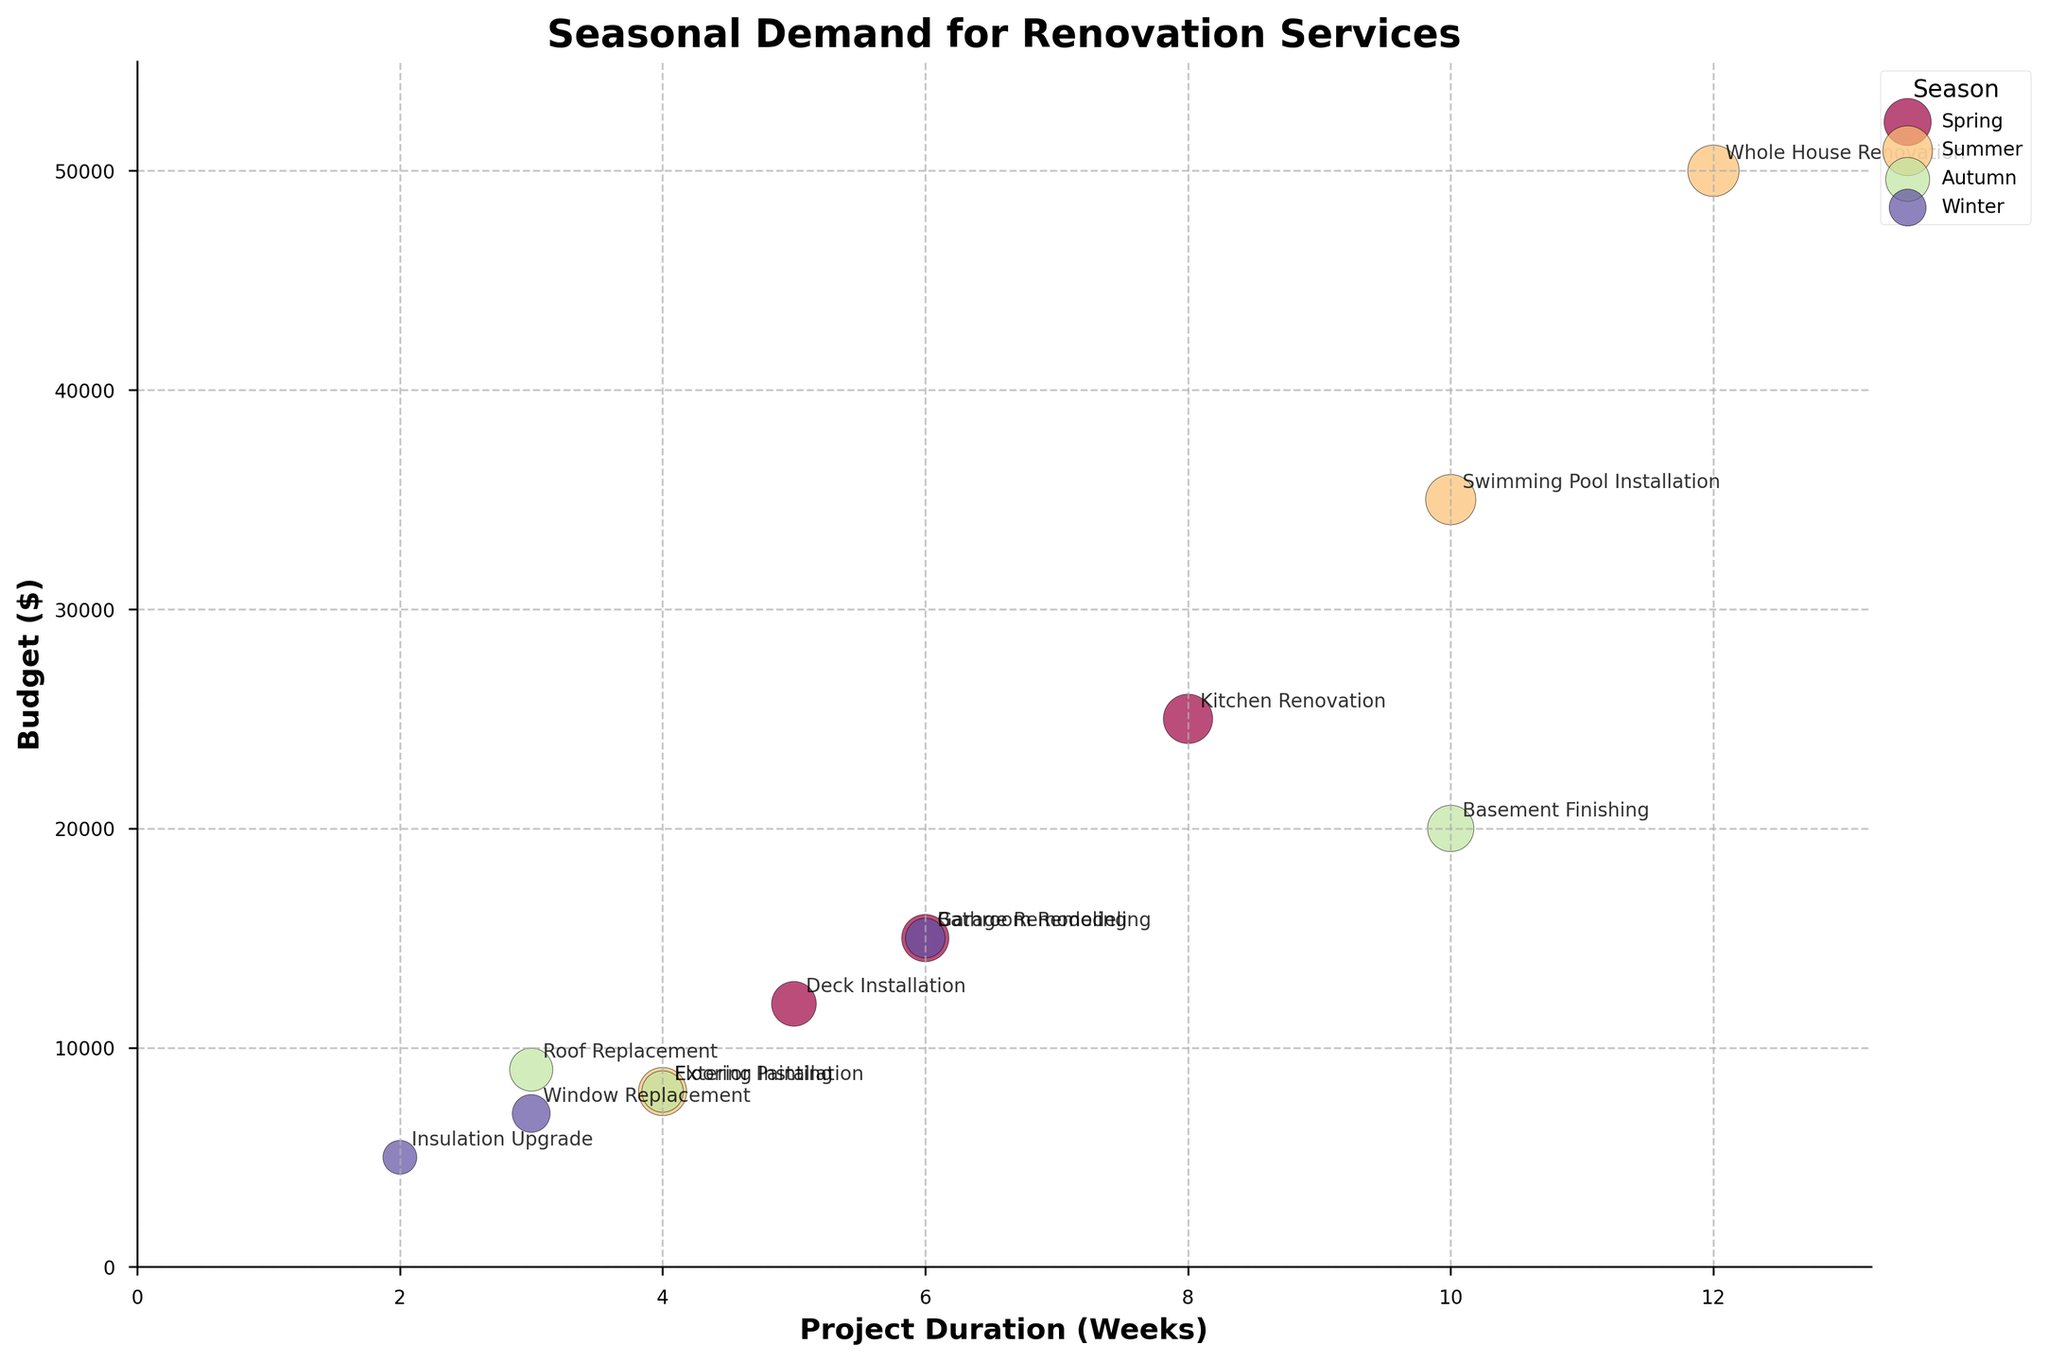What is the title of the chart? The title of the chart is typically mentioned at the top or in the main heading text of the figure. It gives an overview of the information being visualized.
Answer: Seasonal Demand for Renovation Services How many renovation projects are shown for the summer season? Each project is represented as a bubble. By counting the bubbles colored for the summer season and labeled accordingly, we find how many exist.
Answer: 3 Which project has the highest demand index in the winter season? The bubble size corresponds to the demand index. In winter, we locate the largest bubble. By checking the labels, we find the corresponding project.
Answer: Window Replacement What is the average demand index for projects done in autumn? Identify the demand indexes for all autumn projects, then calculate their average: (75 + 65 + 60) / 3 = 66.67.
Answer: 66.67 Which season has the most expensive project, and what is it? Check the highest budget value represented on the y-axis for each season, then identify the corresponding project label.
Answer: Summer, Whole House Renovation Which project has the shortest duration, and what is its demand index? The x-axis corresponds to project duration. Identify the project with the smallest x-value and then check its demand index.
Answer: Insulation Upgrade, 40 In which season is the demand nearly equal for two different projects, and what are those projects? Look for bubbles with sizes that visually appear similar within the same season, then verify with the labels and demand index.
Answer: Spring, Kitchen Renovation and Bathroom Remodeling Compare the demand index of Deck Installation to Flooring Installation. Which is higher? Identify the bubbles for the two projects, note their sizes, and compare the demand indexes directly.
Answer: Deck Installation, 70 > 60 What is the total budget for all projects in the winter season? Add up the budget amounts for all winter projects: 5000 + 7000 + 15000 = 27000.
Answer: 27000 Which project takes the longest duration and in which season is it located? Look for the bubble furthest to the right on the x-axis to determine the longest duration, then note the season.
Answer: Whole House Renovation, Summer 